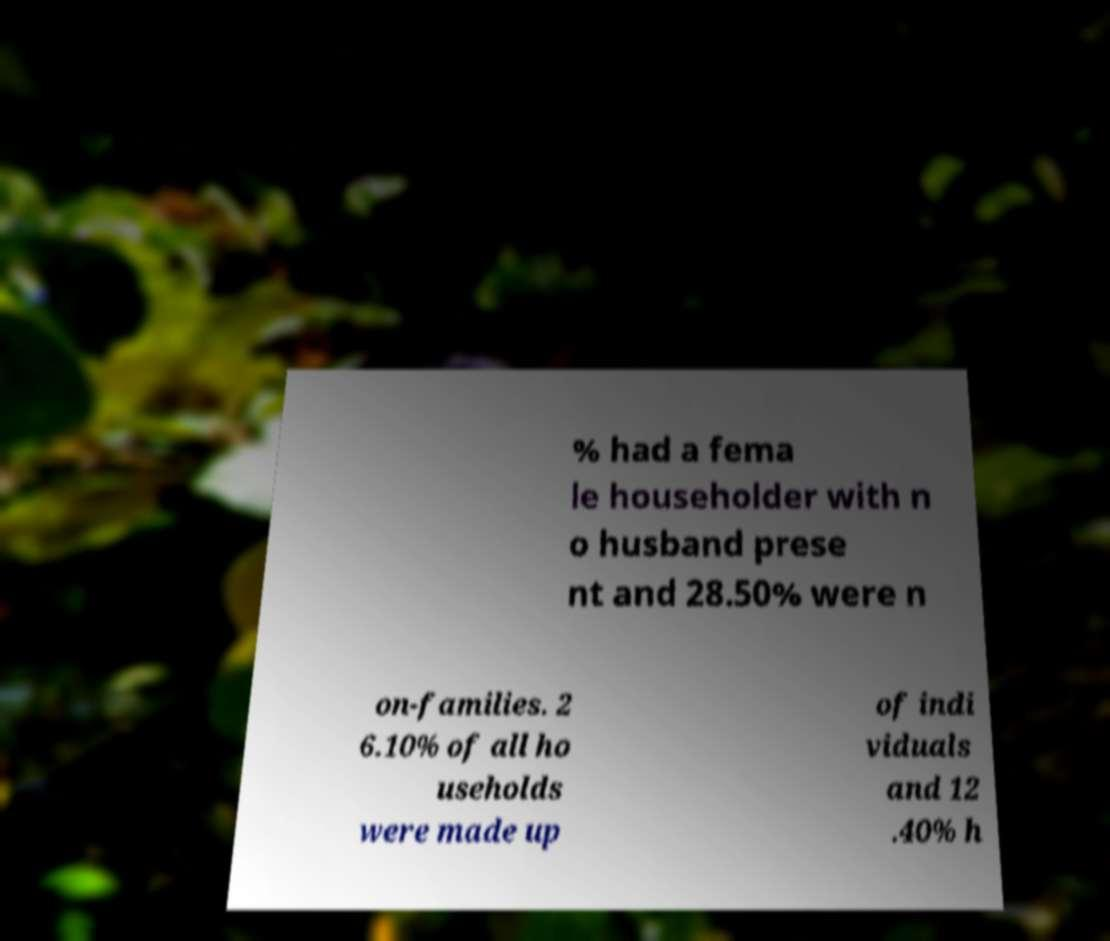I need the written content from this picture converted into text. Can you do that? % had a fema le householder with n o husband prese nt and 28.50% were n on-families. 2 6.10% of all ho useholds were made up of indi viduals and 12 .40% h 